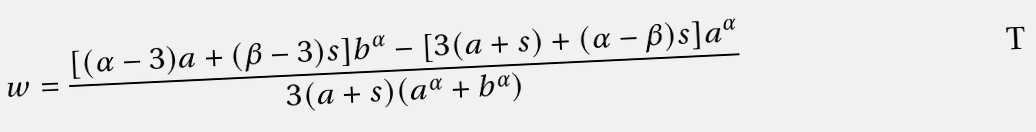<formula> <loc_0><loc_0><loc_500><loc_500>w = \frac { [ ( \alpha - 3 ) a + ( \beta - 3 ) s ] b ^ { \alpha } - [ 3 ( a + s ) + ( \alpha - \beta ) s ] a ^ { \alpha } } { 3 ( a + s ) ( a ^ { \alpha } + b ^ { \alpha } ) }</formula> 